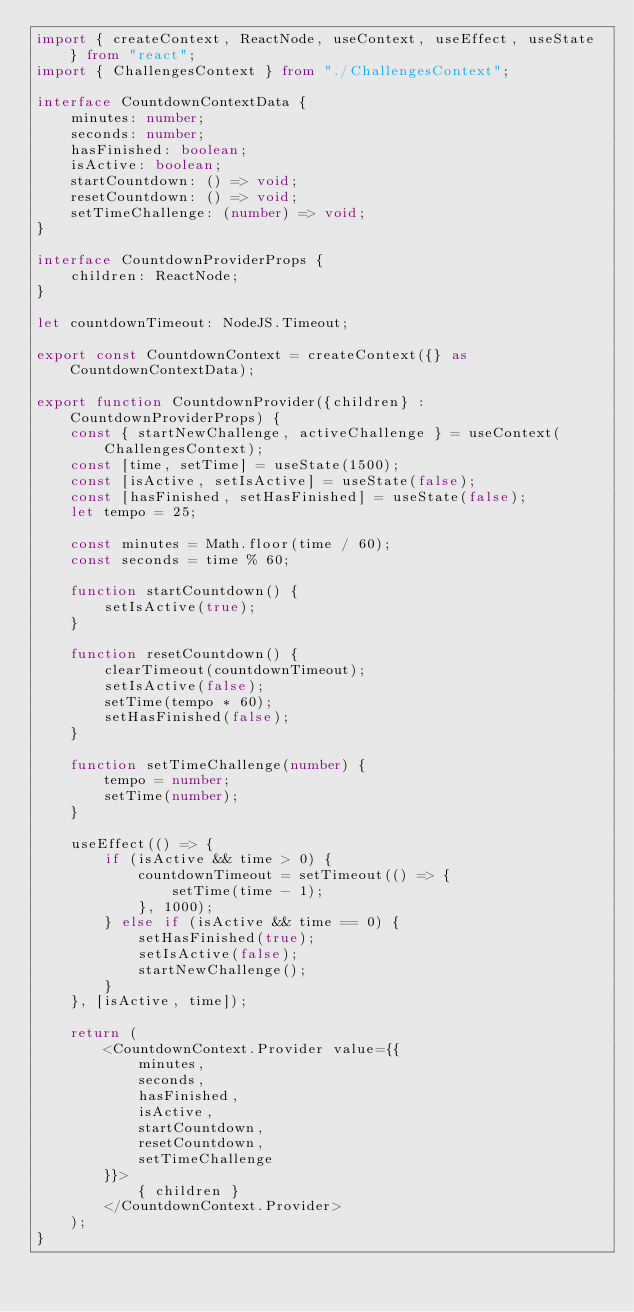Convert code to text. <code><loc_0><loc_0><loc_500><loc_500><_TypeScript_>import { createContext, ReactNode, useContext, useEffect, useState } from "react";
import { ChallengesContext } from "./ChallengesContext";

interface CountdownContextData {
    minutes: number;
    seconds: number;
    hasFinished: boolean;
    isActive: boolean;
    startCountdown: () => void;
    resetCountdown: () => void;
    setTimeChallenge: (number) => void;
}

interface CountdownProviderProps {
    children: ReactNode;
}

let countdownTimeout: NodeJS.Timeout;

export const CountdownContext = createContext({} as CountdownContextData);

export function CountdownProvider({children} : CountdownProviderProps) {
    const { startNewChallenge, activeChallenge } = useContext(ChallengesContext);
    const [time, setTime] = useState(1500);
    const [isActive, setIsActive] = useState(false);
    const [hasFinished, setHasFinished] = useState(false);
    let tempo = 25;

    const minutes = Math.floor(time / 60);
    const seconds = time % 60;

    function startCountdown() {
        setIsActive(true);
    }

    function resetCountdown() {
        clearTimeout(countdownTimeout);
        setIsActive(false);
        setTime(tempo * 60);
        setHasFinished(false);
    }

    function setTimeChallenge(number) {
        tempo = number;
        setTime(number);
    }

    useEffect(() => {
        if (isActive && time > 0) {
            countdownTimeout = setTimeout(() => {
                setTime(time - 1);
            }, 1000);
        } else if (isActive && time == 0) {
            setHasFinished(true);
            setIsActive(false);
            startNewChallenge();
        }
    }, [isActive, time]);

    return (
        <CountdownContext.Provider value={{
            minutes,
            seconds,
            hasFinished,
            isActive,
            startCountdown,
            resetCountdown,
            setTimeChallenge
        }}>
            { children }
        </CountdownContext.Provider>
    );
}
</code> 